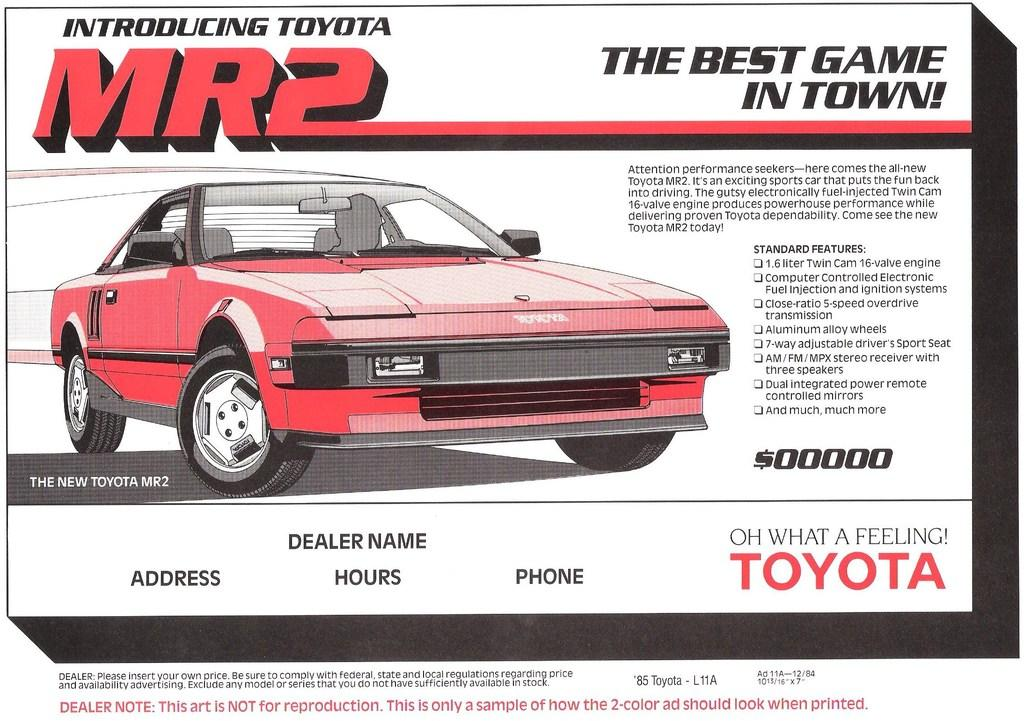What is the main subject of the image? There is a depiction of a red color car in the image. Where can text be found in the image? Text is written on the top, right, and bottom sides of the image. What type of kettle is shown in the image? There is no kettle present in the image. How many thumbs are visible in the image? There is no reference to thumbs or any body parts in the image. 